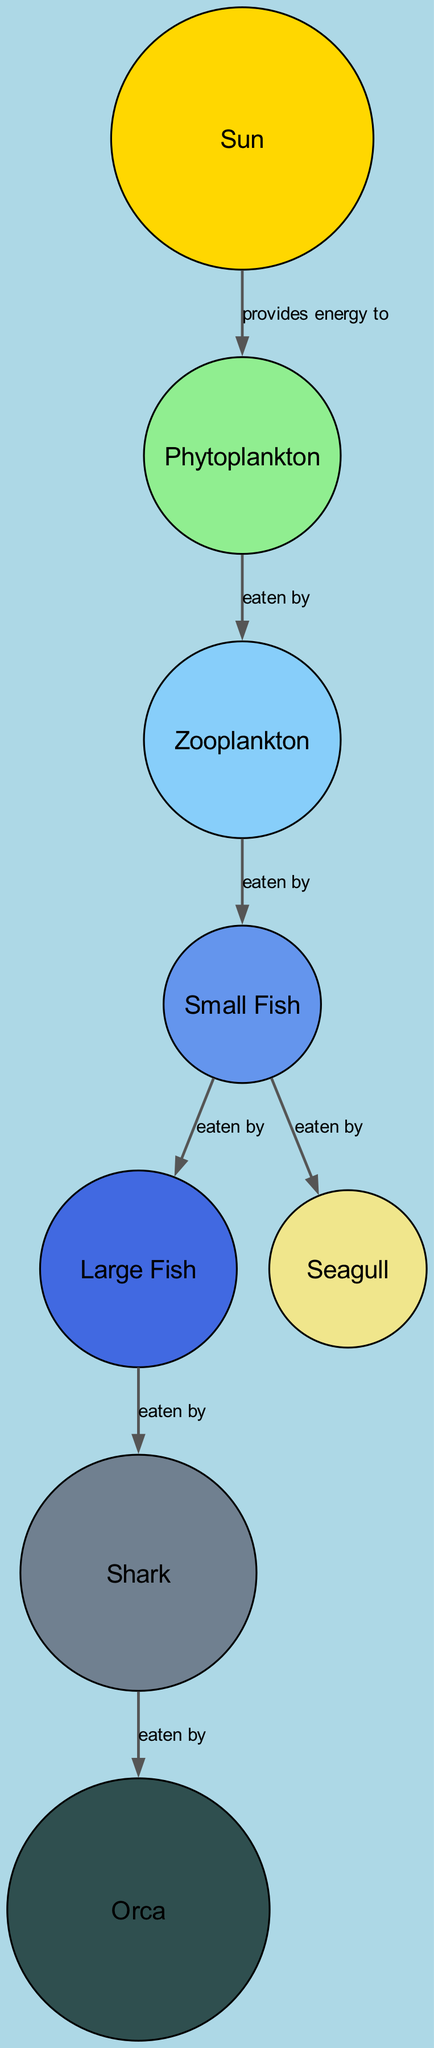What is the main source of energy in the ecosystem? The diagram shows that the Sun provides energy to Phytoplankton, indicating that it is the main energy source.
Answer: Sun How many total nodes are present in the diagram? By counting the nodes listed in the diagram, there are 8 nodes: Sun, Phytoplankton, Zooplankton, Small Fish, Large Fish, Seagull, Shark, and Orca.
Answer: 8 Which organism is at the top of the food chain? The diagram shows that the Orca is the last organism with a relationship indicating it is eaten by a predator, which indicates it's at the top.
Answer: Orca What does Phytoplankton do in this food web? The diagram shows the connection where Phytoplankton is eaten by Zooplankton, indicating that its role is as a producer.
Answer: Eaten by Zooplankton How many organisms eat Small Fish? The diagram illustrates that Small Fish are eaten by both Large Fish and Seagulls, which demonstrates that they have two predators.
Answer: 2 Which predator is directly above Shark in the food web? The diagram indicates that Orca is directly connected to Shark, showing that Orca is Shark's only predator.
Answer: Orca What relationship exists between Zooplankton and Small Fish? The diagram specifies that Zooplankton is eaten by Small Fish, which defines their relationship clearly.
Answer: Eaten by Small Fish Who provides energy to the entire food web? By examining the diagram, we see that the Sun is the only node connected to multiple producers, thus providing energy to the entire food web.
Answer: Sun Which two organisms have the same edge relationship? The diagram shows that both Phytoplankton and Small Fish have the relationship that they are eaten by their respective predators. The term "eaten by" appears for both connections.
Answer: Eaten by 